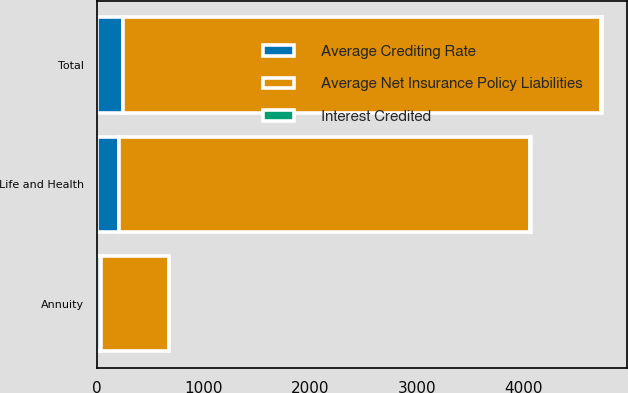Convert chart. <chart><loc_0><loc_0><loc_500><loc_500><stacked_bar_chart><ecel><fcel>Life and Health<fcel>Annuity<fcel>Total<nl><fcel>Average Crediting Rate<fcel>206.3<fcel>31<fcel>237.3<nl><fcel>Average Net Insurance Policy Liabilities<fcel>3857.8<fcel>638.8<fcel>4496.6<nl><fcel>Interest Credited<fcel>5.35<fcel>4.85<fcel>5.28<nl></chart> 